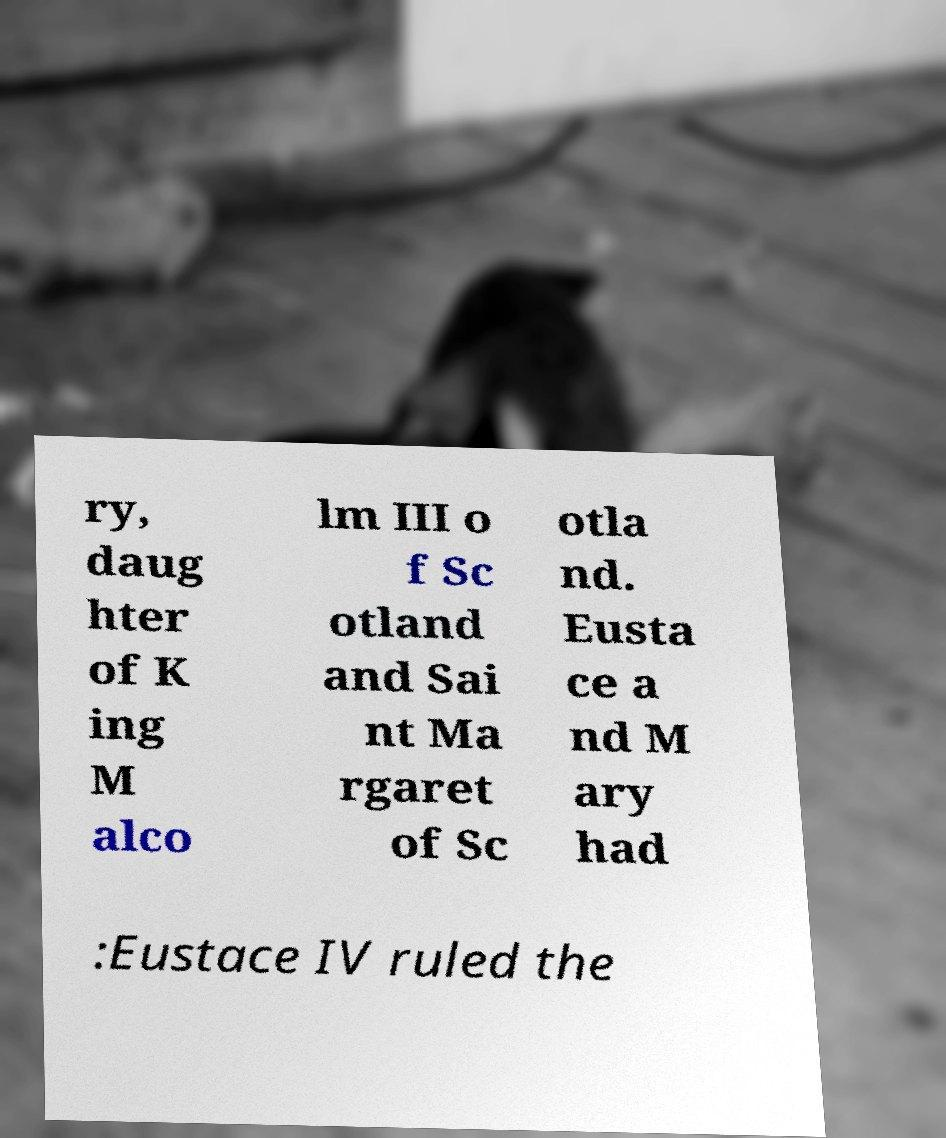I need the written content from this picture converted into text. Can you do that? ry, daug hter of K ing M alco lm III o f Sc otland and Sai nt Ma rgaret of Sc otla nd. Eusta ce a nd M ary had :Eustace IV ruled the 